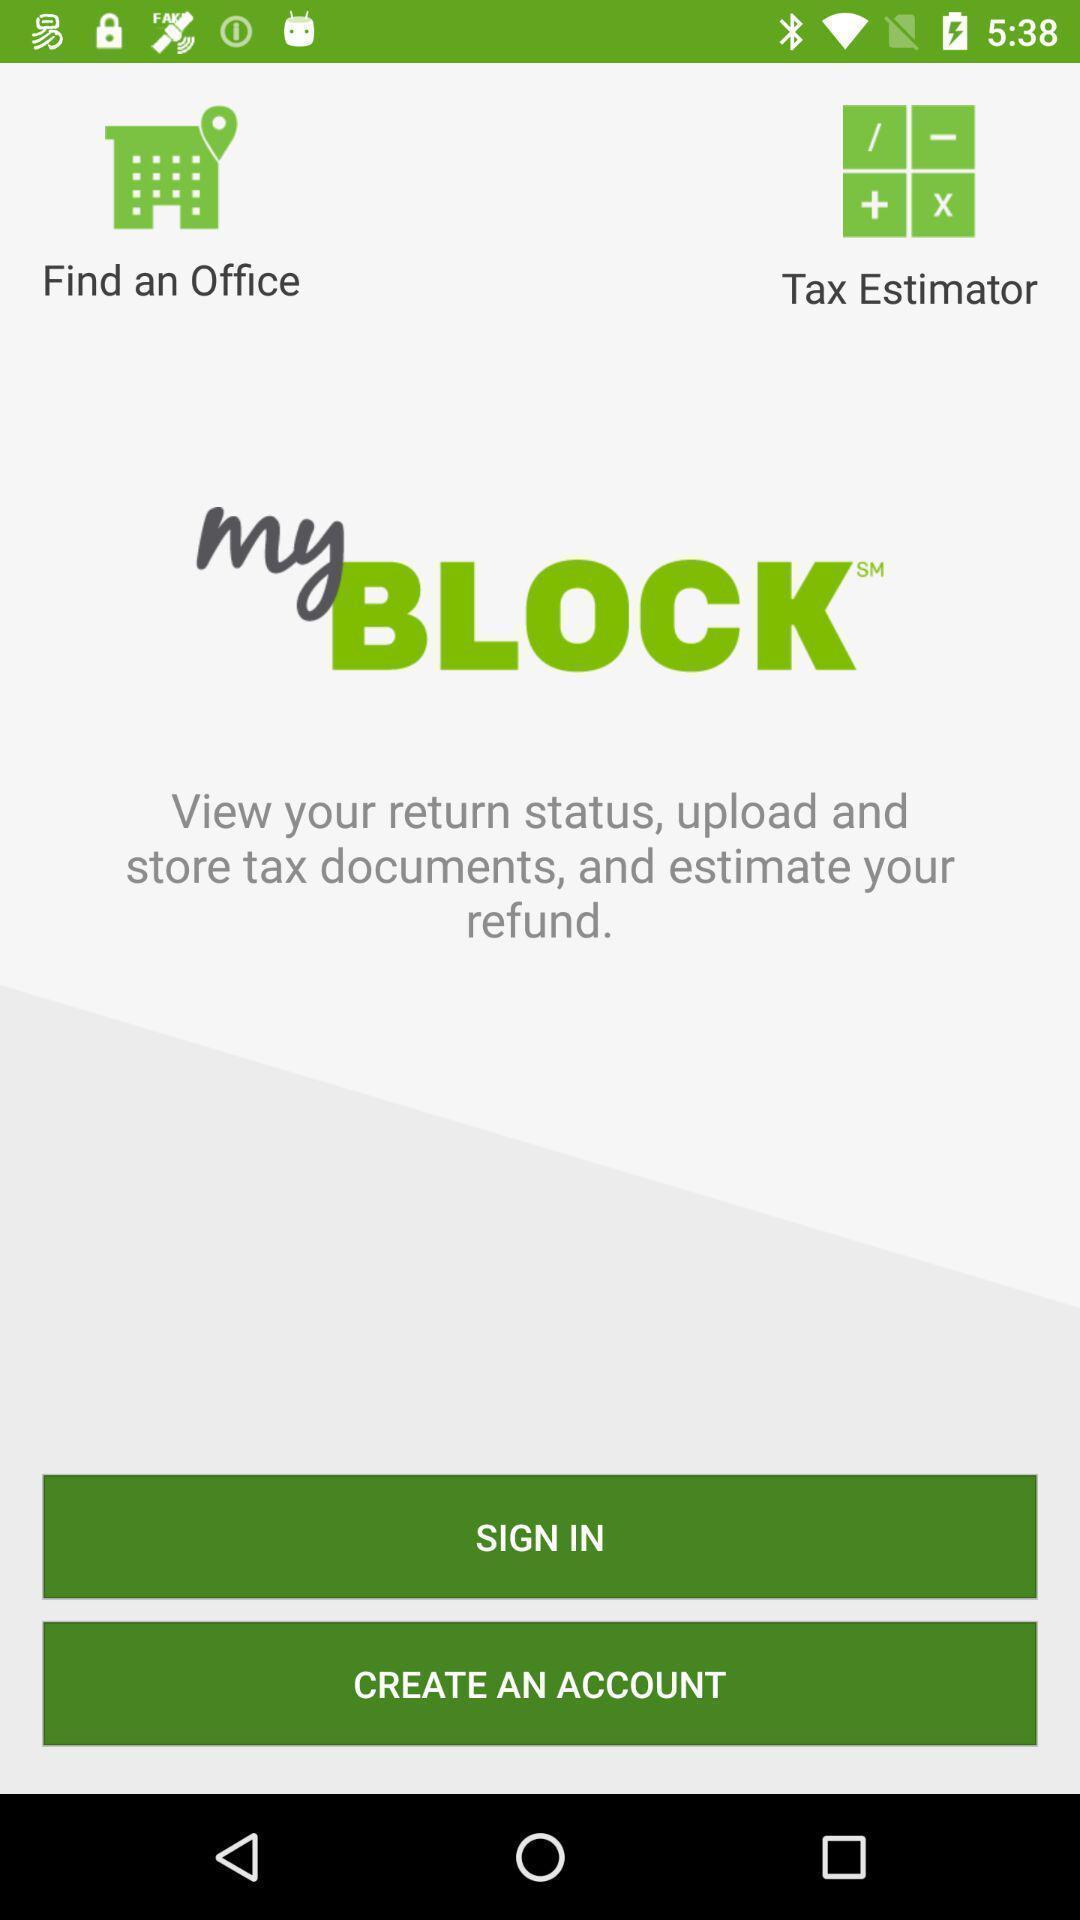Tell me about the visual elements in this screen capture. Welcome page for tax managing app. 